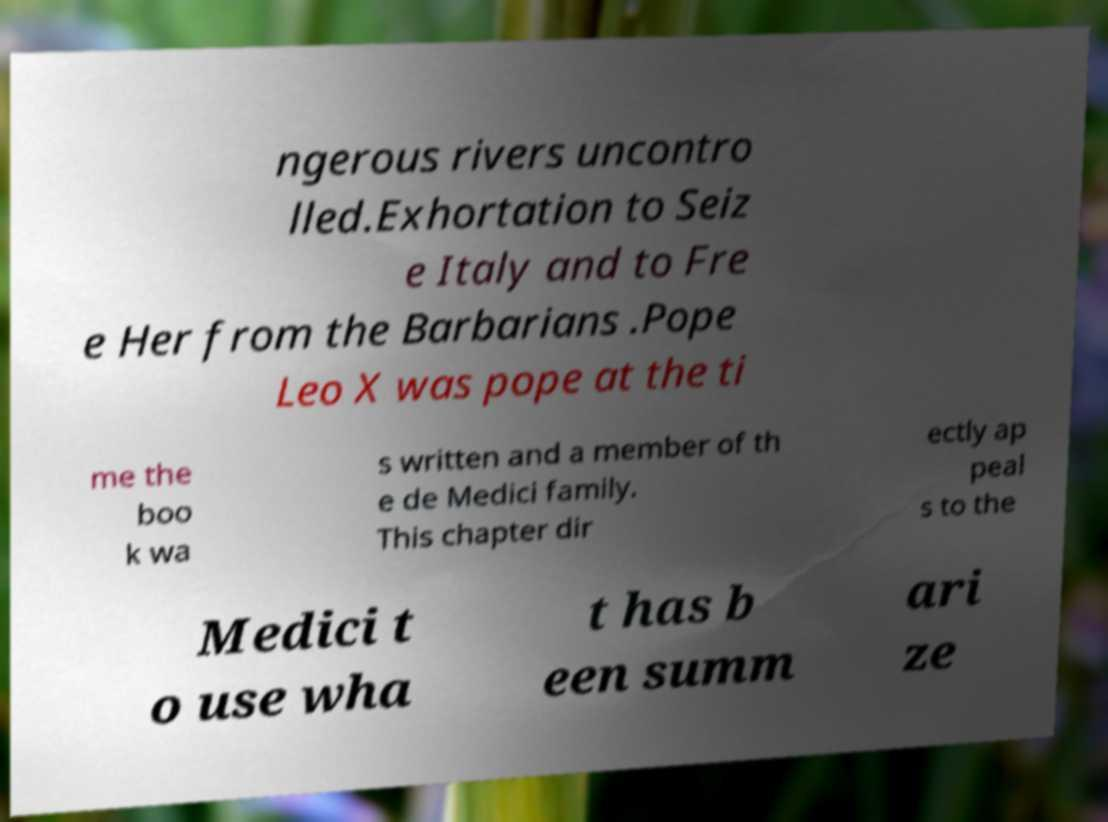Could you assist in decoding the text presented in this image and type it out clearly? ngerous rivers uncontro lled.Exhortation to Seiz e Italy and to Fre e Her from the Barbarians .Pope Leo X was pope at the ti me the boo k wa s written and a member of th e de Medici family. This chapter dir ectly ap peal s to the Medici t o use wha t has b een summ ari ze 